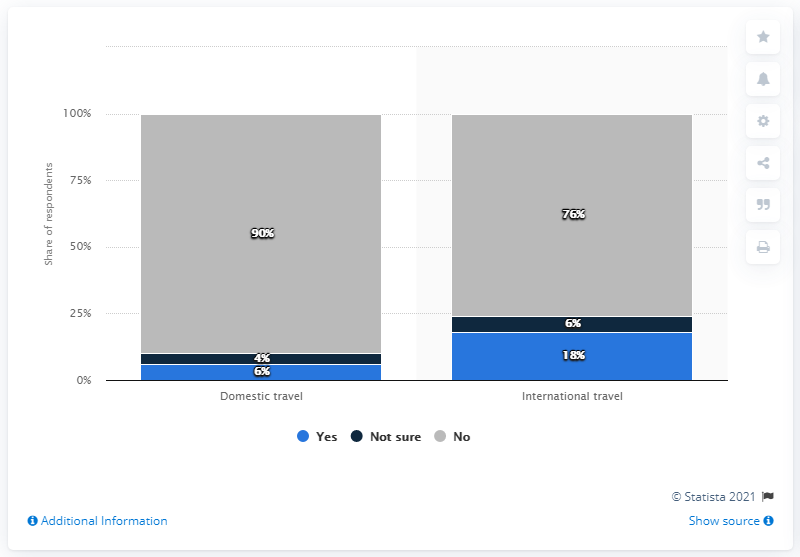Draw attention to some important aspects in this diagram. The study found that domestic travel and international travel were equally popular among respondents who answered "yes" to the survey question, with a ratio of 0.33. The sum of the gray bar is 166. 